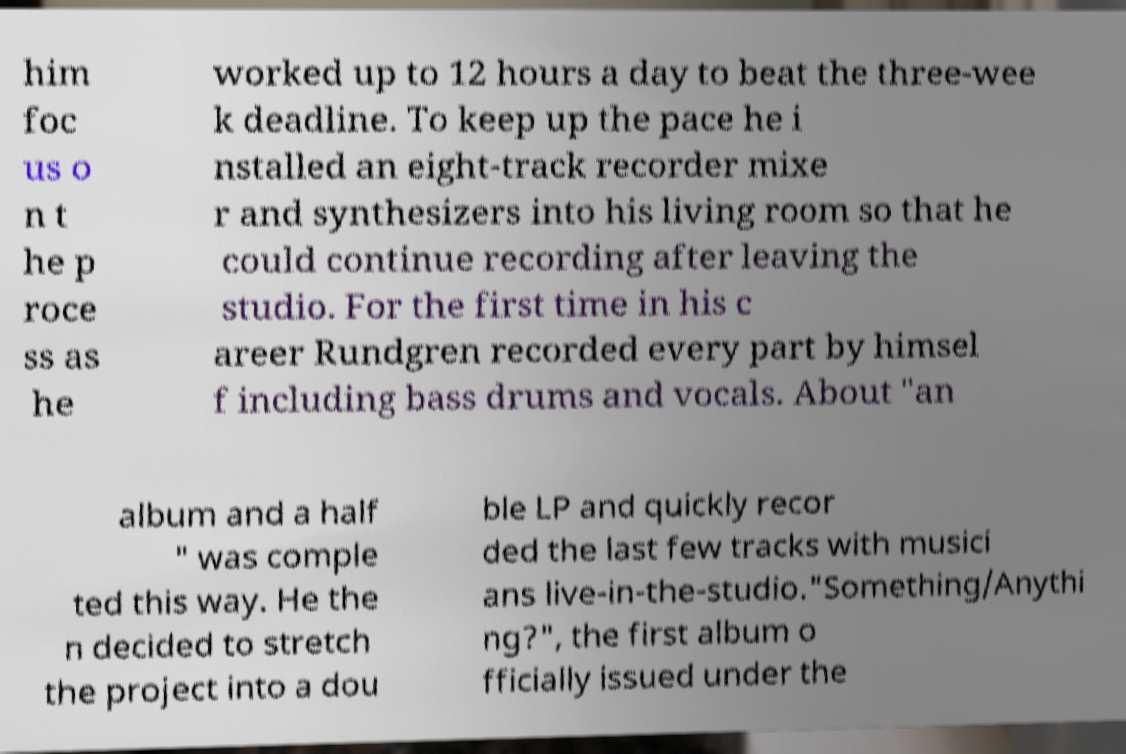Could you extract and type out the text from this image? him foc us o n t he p roce ss as he worked up to 12 hours a day to beat the three-wee k deadline. To keep up the pace he i nstalled an eight-track recorder mixe r and synthesizers into his living room so that he could continue recording after leaving the studio. For the first time in his c areer Rundgren recorded every part by himsel f including bass drums and vocals. About "an album and a half " was comple ted this way. He the n decided to stretch the project into a dou ble LP and quickly recor ded the last few tracks with musici ans live-in-the-studio."Something/Anythi ng?", the first album o fficially issued under the 